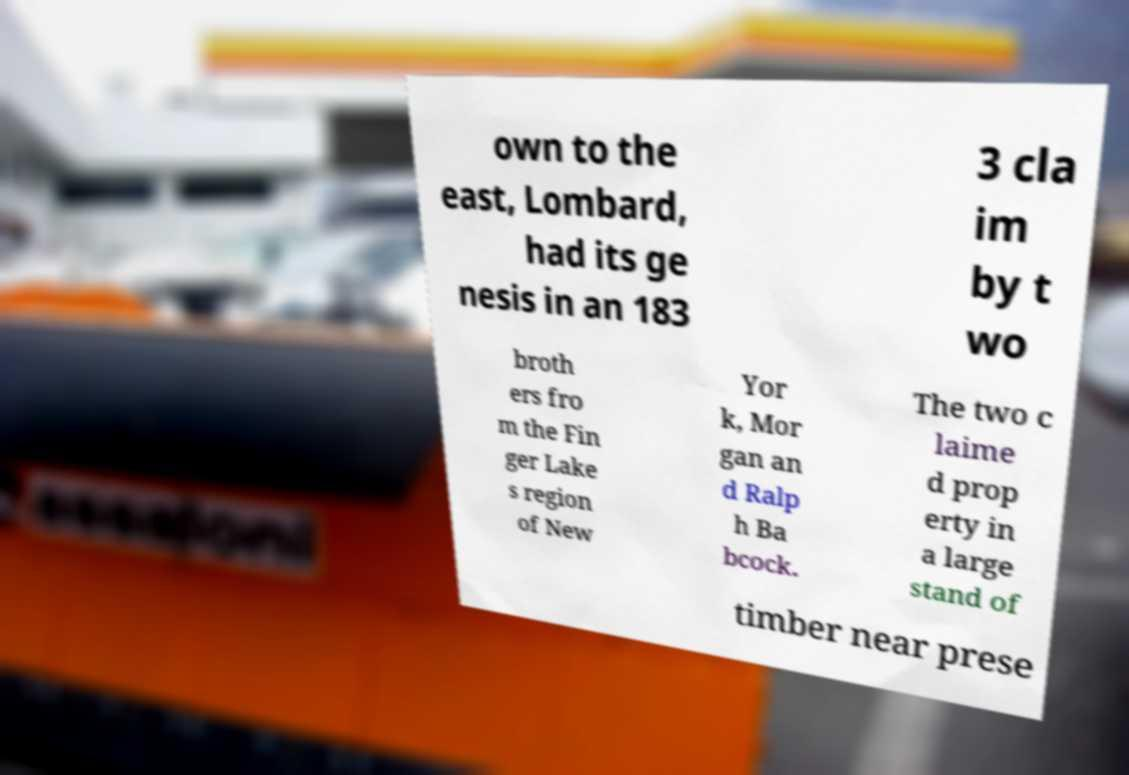Could you extract and type out the text from this image? own to the east, Lombard, had its ge nesis in an 183 3 cla im by t wo broth ers fro m the Fin ger Lake s region of New Yor k, Mor gan an d Ralp h Ba bcock. The two c laime d prop erty in a large stand of timber near prese 